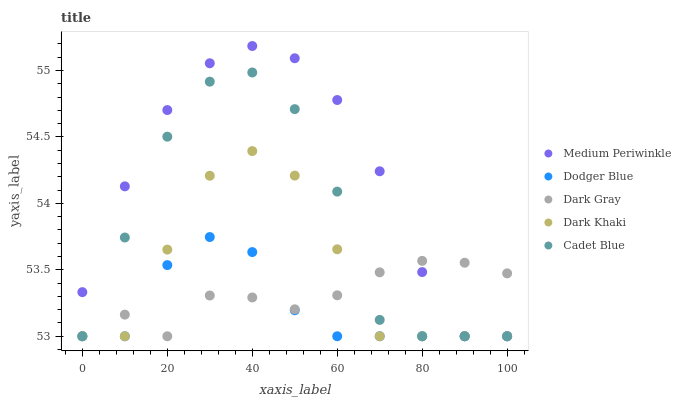Does Dodger Blue have the minimum area under the curve?
Answer yes or no. Yes. Does Medium Periwinkle have the maximum area under the curve?
Answer yes or no. Yes. Does Cadet Blue have the minimum area under the curve?
Answer yes or no. No. Does Cadet Blue have the maximum area under the curve?
Answer yes or no. No. Is Dark Gray the smoothest?
Answer yes or no. Yes. Is Cadet Blue the roughest?
Answer yes or no. Yes. Is Dodger Blue the smoothest?
Answer yes or no. No. Is Dodger Blue the roughest?
Answer yes or no. No. Does Dark Gray have the lowest value?
Answer yes or no. Yes. Does Medium Periwinkle have the highest value?
Answer yes or no. Yes. Does Dodger Blue have the highest value?
Answer yes or no. No. Does Dodger Blue intersect Medium Periwinkle?
Answer yes or no. Yes. Is Dodger Blue less than Medium Periwinkle?
Answer yes or no. No. Is Dodger Blue greater than Medium Periwinkle?
Answer yes or no. No. 